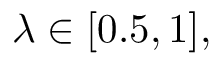Convert formula to latex. <formula><loc_0><loc_0><loc_500><loc_500>\lambda \in [ 0 . 5 , 1 ] ,</formula> 